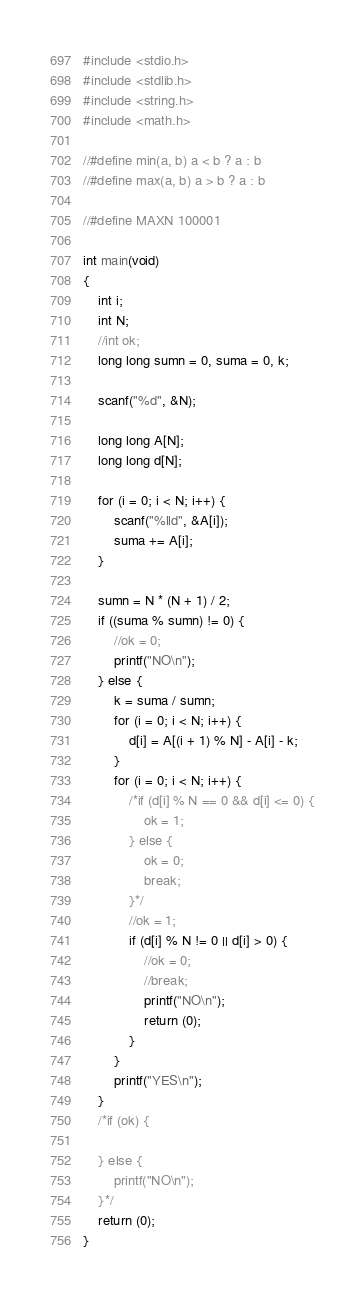Convert code to text. <code><loc_0><loc_0><loc_500><loc_500><_C_>#include <stdio.h>
#include <stdlib.h>
#include <string.h>
#include <math.h>

//#define min(a, b) a < b ? a : b
//#define max(a, b) a > b ? a : b

//#define MAXN 100001

int main(void)
{
	int i;
	int N;
	//int ok;
	long long sumn = 0, suma = 0, k;

	scanf("%d", &N);

	long long A[N];
	long long d[N];

	for (i = 0; i < N; i++) {
		scanf("%lld", &A[i]);
		suma += A[i];
	}

	sumn = N * (N + 1) / 2;
	if ((suma % sumn) != 0) {
		//ok = 0;
		printf("NO\n");
	} else {
		k = suma / sumn;
		for (i = 0; i < N; i++) {
			d[i] = A[(i + 1) % N] - A[i] - k;
		}
		for (i = 0; i < N; i++) {
			/*if (d[i] % N == 0 && d[i] <= 0) {
				ok = 1;
			} else {
				ok = 0;
				break;
			}*/
			//ok = 1;
			if (d[i] % N != 0 || d[i] > 0) {
				//ok = 0;
				//break;
				printf("NO\n");
				return (0);
			}
		}
		printf("YES\n");
	}
	/*if (ok) {
		
	} else {
		printf("NO\n");
	}*/
	return (0);
}</code> 